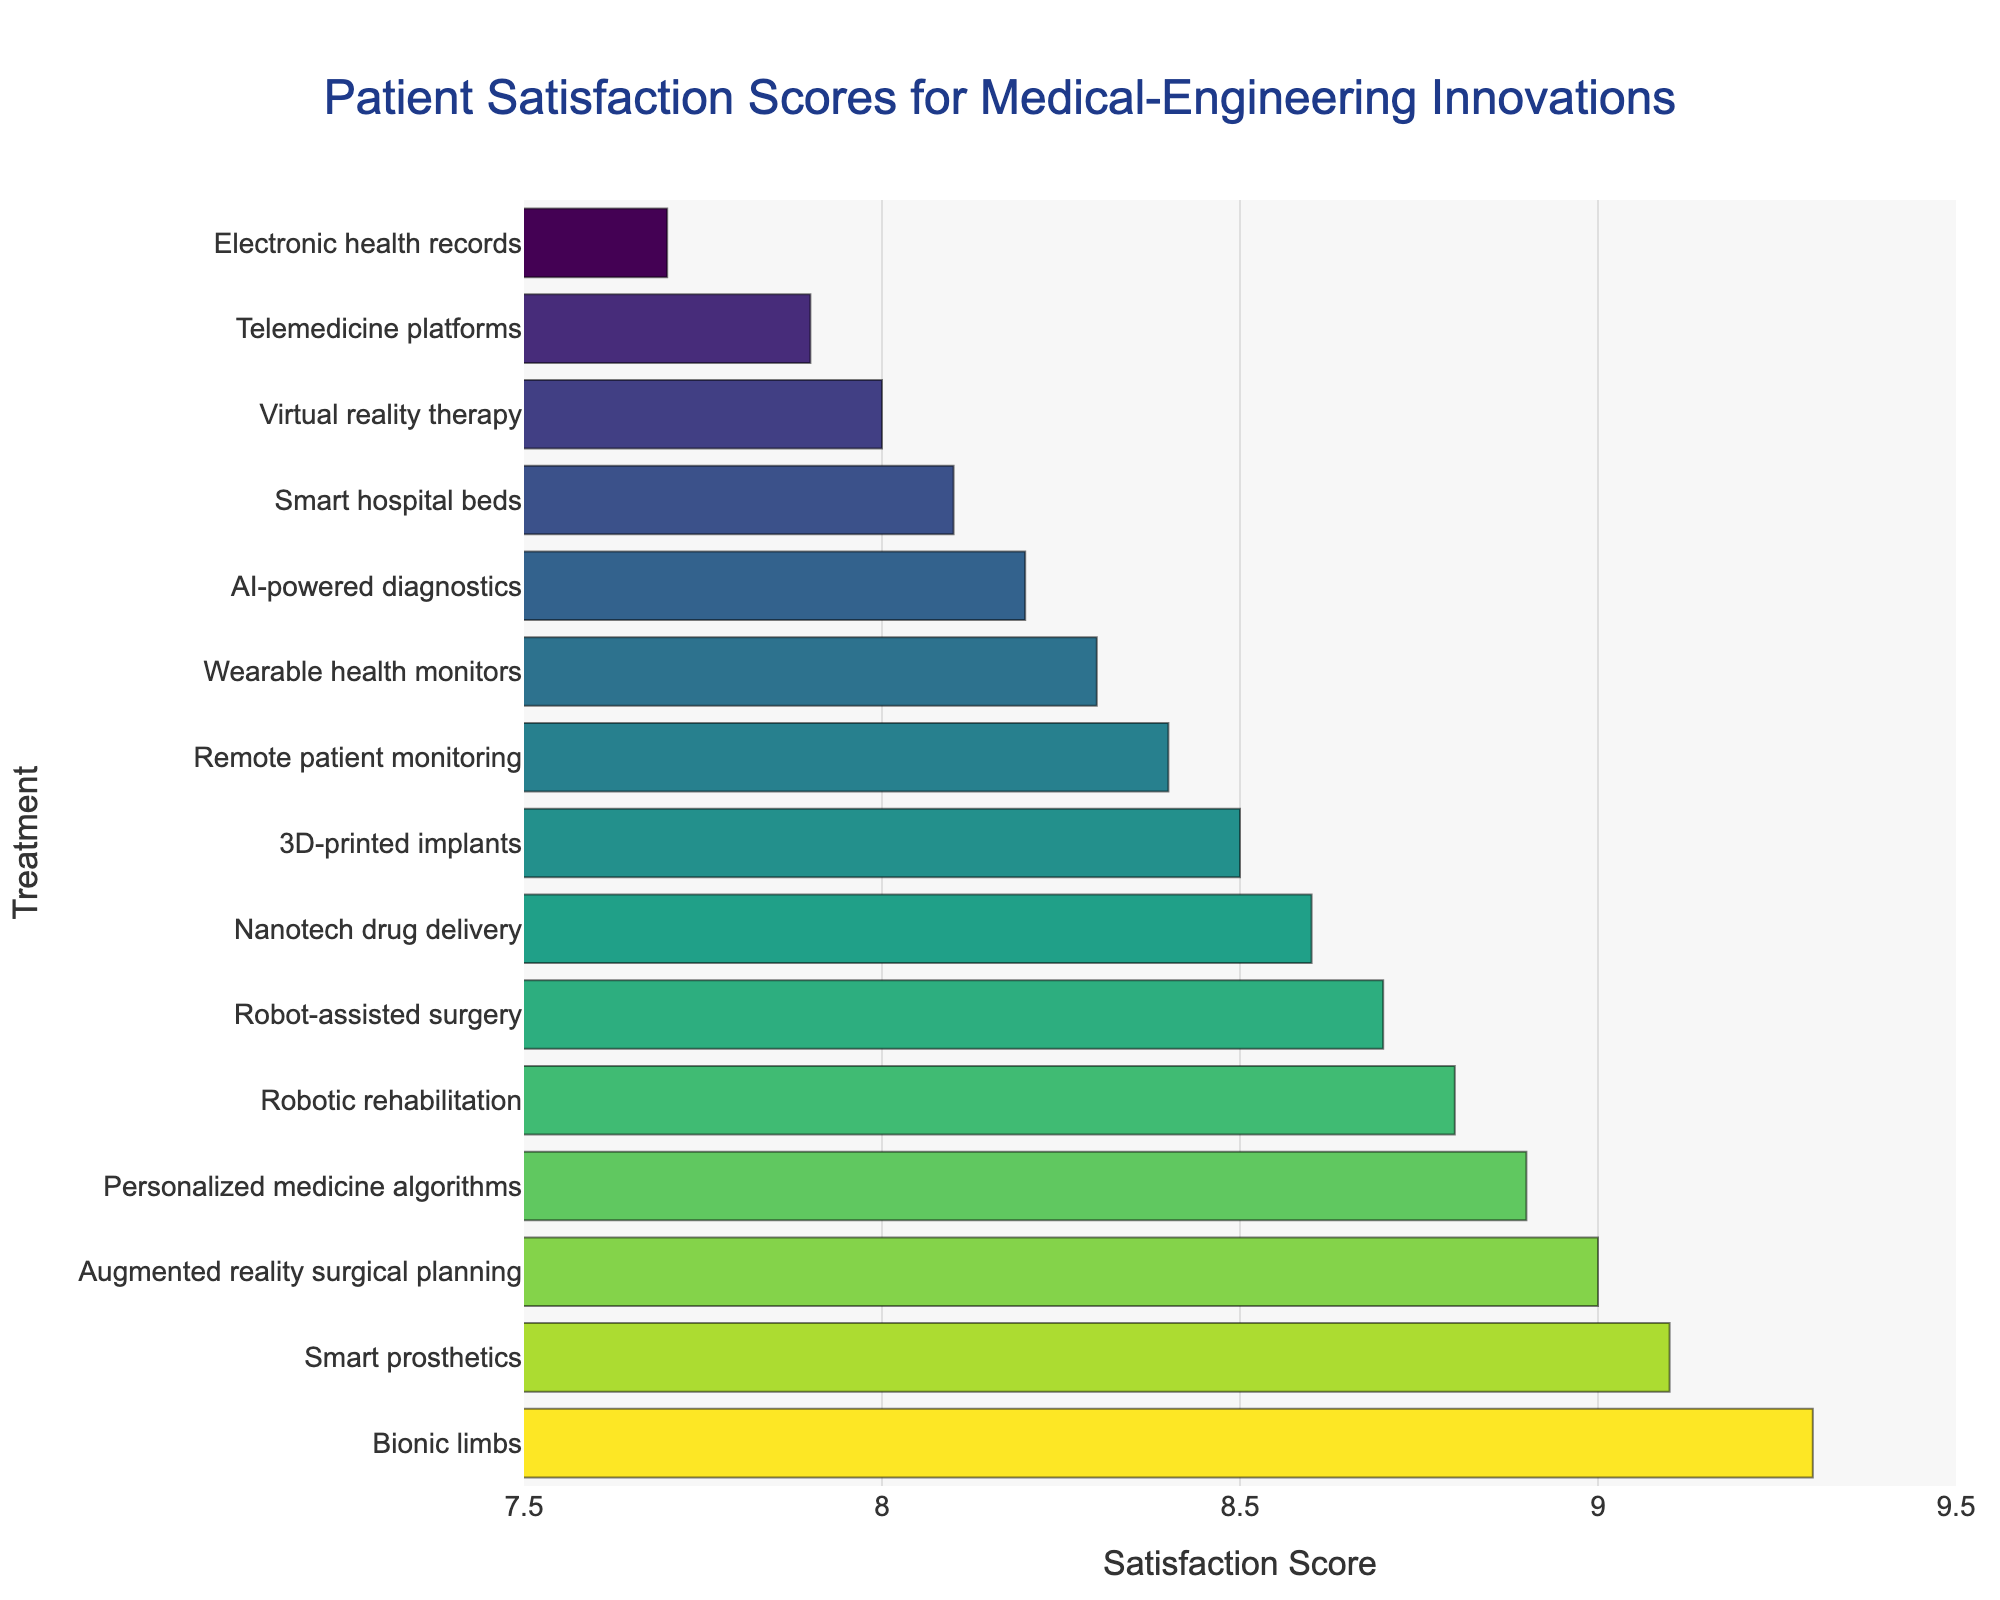Which treatment has the highest satisfaction score? Identify the treatment with the longest bar, indicating the highest satisfaction score.
Answer: Bionic limbs Which treatment has the lowest satisfaction score? Look for the treatment where the bar is the shortest.
Answer: Electronic health records How many treatments have a satisfaction score above 8.5? Count the bars whose lengths correspond to a satisfaction score greater than 8.5.
Answer: 6 What is the difference in satisfaction score between Bionic limbs and Telemedicine platforms? Subtract the satisfaction score of Telemedicine platforms from that of Bionic limbs (9.3 - 7.9).
Answer: 1.4 Which treatment has a higher satisfaction score: AI-powered diagnostics or Remote patient monitoring? Compare the lengths of the bars for AI-powered diagnostics and Remote patient monitoring.
Answer: Remote patient monitoring What is the median satisfaction score of all the treatments? List all satisfaction scores in ascending order and find the middle value: 7.7, 7.9, 8.0, 8.1, 8.2, 8.3, 8.4, 8.5, 8.6, 8.7, 8.8, 8.9, 9.0, 9.1, 9.3. The median is the 8th value in this 15-element list.
Answer: 8.5 How much higher is the satisfaction score for Smart prosthetics than for Virtual reality therapy? Subtract the satisfaction score of Virtual reality therapy from that of Smart prosthetics (9.1 - 8.0).
Answer: 1.1 Which has a higher satisfaction score: Robot-assisted surgery or Augmented reality surgical planning? Compare the lengths of the bars for Robot-assisted surgery and Augmented reality surgical planning.
Answer: Augmented reality surgical planning What is the average satisfaction score of treatments with scores above 9.0? Find the scores above 9.0: 9.1, 9.3, 8.9, 9.0. Sum them up (9.1 + 9.3 + 8.9 + 9.0 = 36.3) and divide by the number of treatments (4).
Answer: 9.075 How does the color change as the satisfaction score increases? Observe the color transition along the bar chart as the satisfaction score increases.
Answer: It transitions from green to yellow 